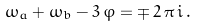Convert formula to latex. <formula><loc_0><loc_0><loc_500><loc_500>\omega _ { a } + \omega _ { b } - 3 \, \varphi = \mp \, 2 \, \pi \, i \, .</formula> 